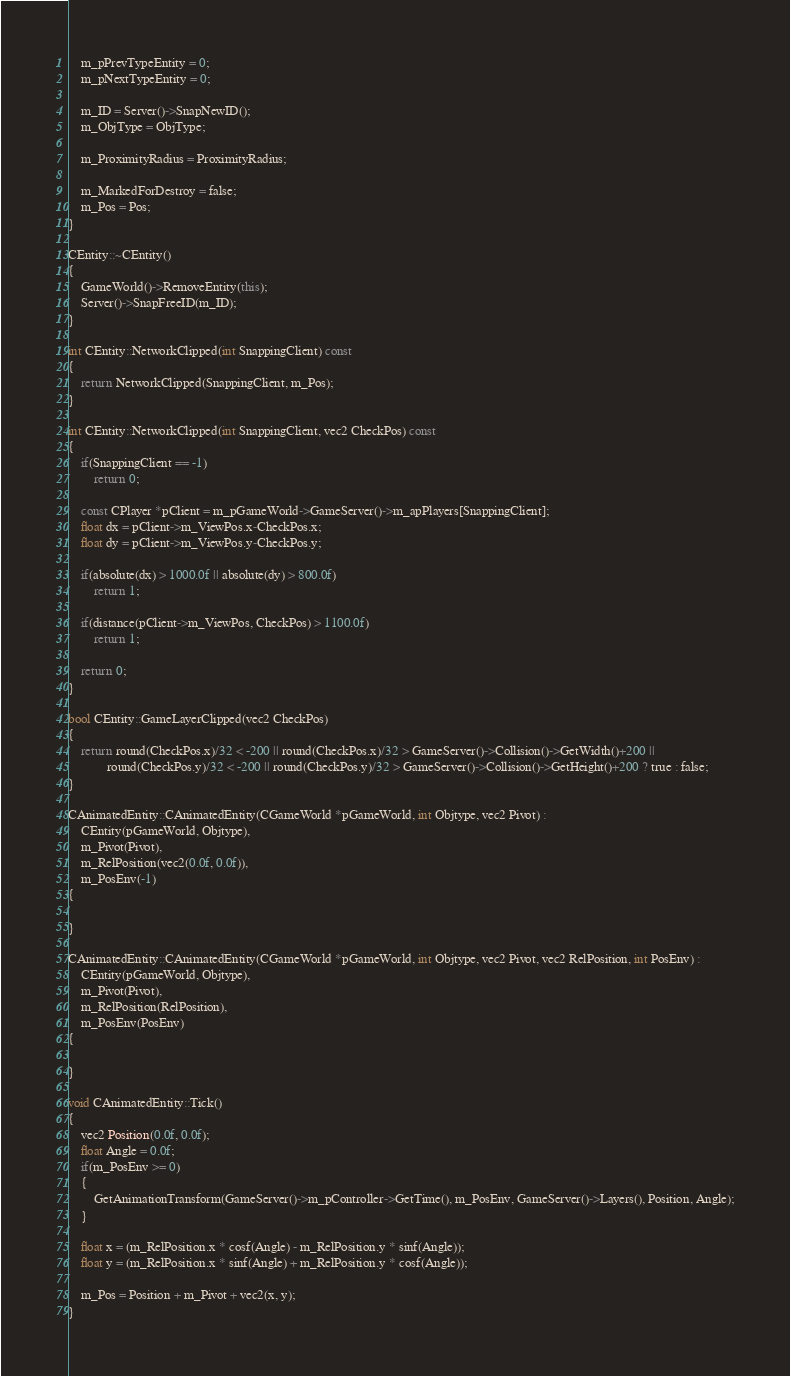Convert code to text. <code><loc_0><loc_0><loc_500><loc_500><_C++_>
	m_pPrevTypeEntity = 0;
	m_pNextTypeEntity = 0;
	
	m_ID = Server()->SnapNewID();
	m_ObjType = ObjType;
	
	m_ProximityRadius = ProximityRadius;

	m_MarkedForDestroy = false;
	m_Pos = Pos;
}

CEntity::~CEntity()
{
	GameWorld()->RemoveEntity(this);
	Server()->SnapFreeID(m_ID);
}

int CEntity::NetworkClipped(int SnappingClient) const
{
	return NetworkClipped(SnappingClient, m_Pos);
}

int CEntity::NetworkClipped(int SnappingClient, vec2 CheckPos) const
{
	if(SnappingClient == -1)
		return 0;

	const CPlayer *pClient = m_pGameWorld->GameServer()->m_apPlayers[SnappingClient];
	float dx = pClient->m_ViewPos.x-CheckPos.x;
	float dy = pClient->m_ViewPos.y-CheckPos.y;

	if(absolute(dx) > 1000.0f || absolute(dy) > 800.0f)
		return 1;

	if(distance(pClient->m_ViewPos, CheckPos) > 1100.0f)
		return 1;

	return 0;
}

bool CEntity::GameLayerClipped(vec2 CheckPos)
{
	return round(CheckPos.x)/32 < -200 || round(CheckPos.x)/32 > GameServer()->Collision()->GetWidth()+200 ||
			round(CheckPos.y)/32 < -200 || round(CheckPos.y)/32 > GameServer()->Collision()->GetHeight()+200 ? true : false;
}

CAnimatedEntity::CAnimatedEntity(CGameWorld *pGameWorld, int Objtype, vec2 Pivot) :
	CEntity(pGameWorld, Objtype),
	m_Pivot(Pivot),
	m_RelPosition(vec2(0.0f, 0.0f)),
	m_PosEnv(-1)
{
	
}

CAnimatedEntity::CAnimatedEntity(CGameWorld *pGameWorld, int Objtype, vec2 Pivot, vec2 RelPosition, int PosEnv) :
	CEntity(pGameWorld, Objtype),
	m_Pivot(Pivot),
	m_RelPosition(RelPosition),
	m_PosEnv(PosEnv)
{
	
}

void CAnimatedEntity::Tick()
{
	vec2 Position(0.0f, 0.0f);
	float Angle = 0.0f;
	if(m_PosEnv >= 0)
	{
		GetAnimationTransform(GameServer()->m_pController->GetTime(), m_PosEnv, GameServer()->Layers(), Position, Angle);
	}
	
	float x = (m_RelPosition.x * cosf(Angle) - m_RelPosition.y * sinf(Angle));
	float y = (m_RelPosition.x * sinf(Angle) + m_RelPosition.y * cosf(Angle));
	
	m_Pos = Position + m_Pivot + vec2(x, y);
}
</code> 